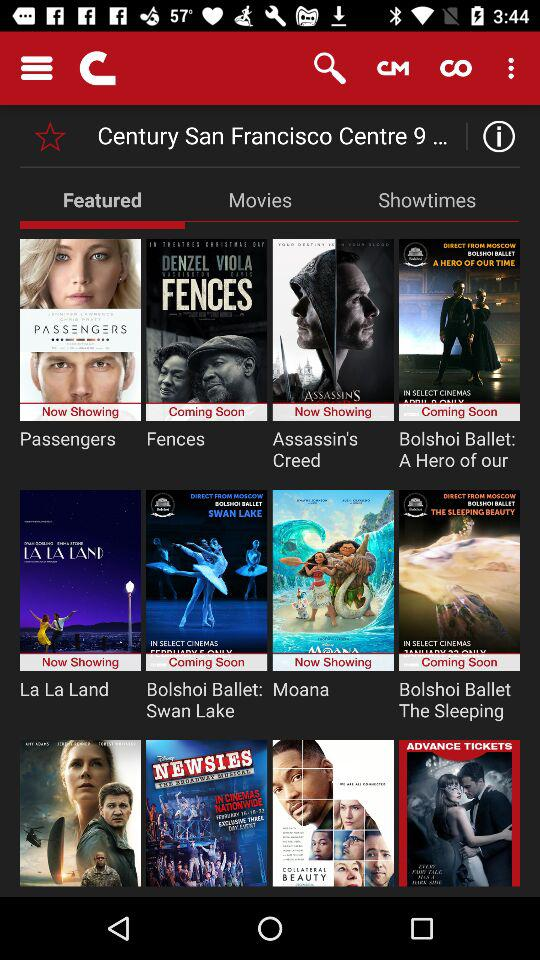Which tab is selected? The selected tab is "Featured". 